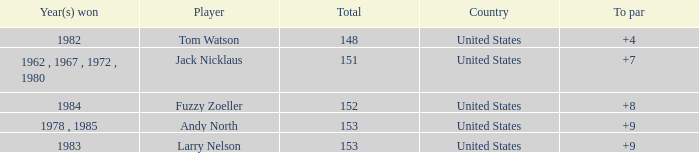What is Andy North with a To par greater than 8 Country? United States. Would you mind parsing the complete table? {'header': ['Year(s) won', 'Player', 'Total', 'Country', 'To par'], 'rows': [['1982', 'Tom Watson', '148', 'United States', '+4'], ['1962 , 1967 , 1972 , 1980', 'Jack Nicklaus', '151', 'United States', '+7'], ['1984', 'Fuzzy Zoeller', '152', 'United States', '+8'], ['1978 , 1985', 'Andy North', '153', 'United States', '+9'], ['1983', 'Larry Nelson', '153', 'United States', '+9']]} 